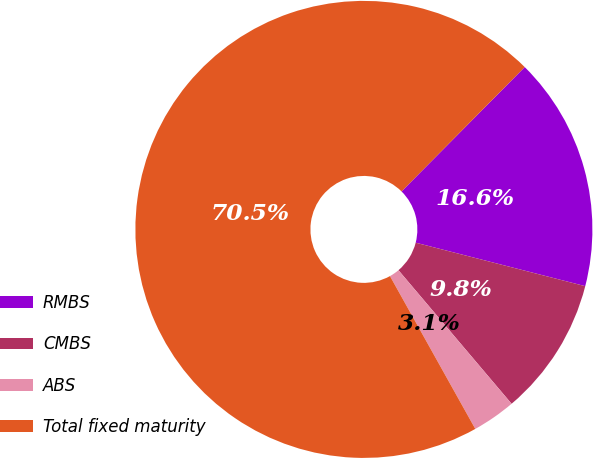Convert chart to OTSL. <chart><loc_0><loc_0><loc_500><loc_500><pie_chart><fcel>RMBS<fcel>CMBS<fcel>ABS<fcel>Total fixed maturity<nl><fcel>16.57%<fcel>9.82%<fcel>3.08%<fcel>70.53%<nl></chart> 